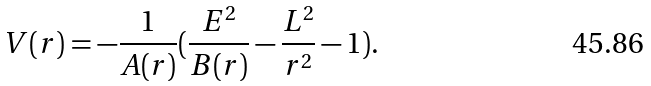Convert formula to latex. <formula><loc_0><loc_0><loc_500><loc_500>V ( r ) = - { \frac { 1 } { A ( r ) } } ( { \frac { E ^ { 2 } } { B ( r ) } } - { \frac { L ^ { 2 } } { r ^ { 2 } } } - 1 ) .</formula> 